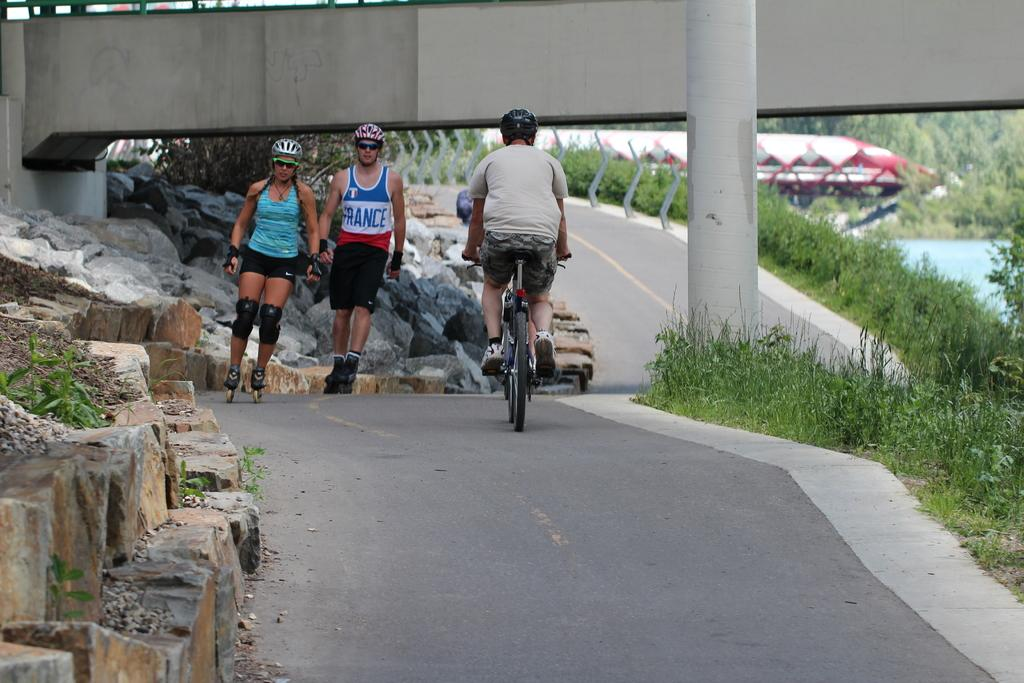What type of vegetation can be seen in the image? There are trees in the image. What else can be seen on the ground in the image? There is grass in the image. What structure is present in the image that allows people to cross a body of water? There is a bridge in the image. How many people are visible on the road in the image? There are two people on the road in the image. What mode of transportation is being used by one of the individuals in the image? There is a man riding a bicycle in the image. What type of rice is being cooked in the image? There is no rice present in the image; it features trees, grass, a bridge, and people. What industry is depicted in the image? There is no industry depicted in the image; it focuses on natural elements and human activities. 